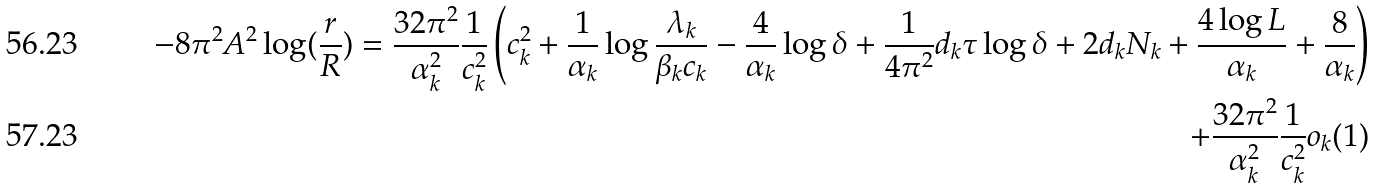<formula> <loc_0><loc_0><loc_500><loc_500>- 8 \pi ^ { 2 } A ^ { 2 } \log ( \frac { r } { R } ) = \frac { 3 2 \pi ^ { 2 } } { \alpha _ { k } ^ { 2 } } \frac { 1 } { c _ { k } ^ { 2 } } \left ( c _ { k } ^ { 2 } + \frac { 1 } { \alpha _ { k } } \log \frac { \lambda _ { k } } { \beta _ { k } c _ { k } } - \frac { 4 } { \alpha _ { k } } \log \delta + \frac { 1 } { 4 \pi ^ { 2 } } d _ { k } \tau \log \delta + 2 d _ { k } N _ { k } + \frac { 4 \log L } { \alpha _ { k } } + \frac { 8 } { \alpha _ { k } } \right ) \\ + \frac { 3 2 \pi ^ { 2 } } { \alpha _ { k } ^ { 2 } } \frac { 1 } { c _ { k } ^ { 2 } } o _ { k } ( 1 )</formula> 